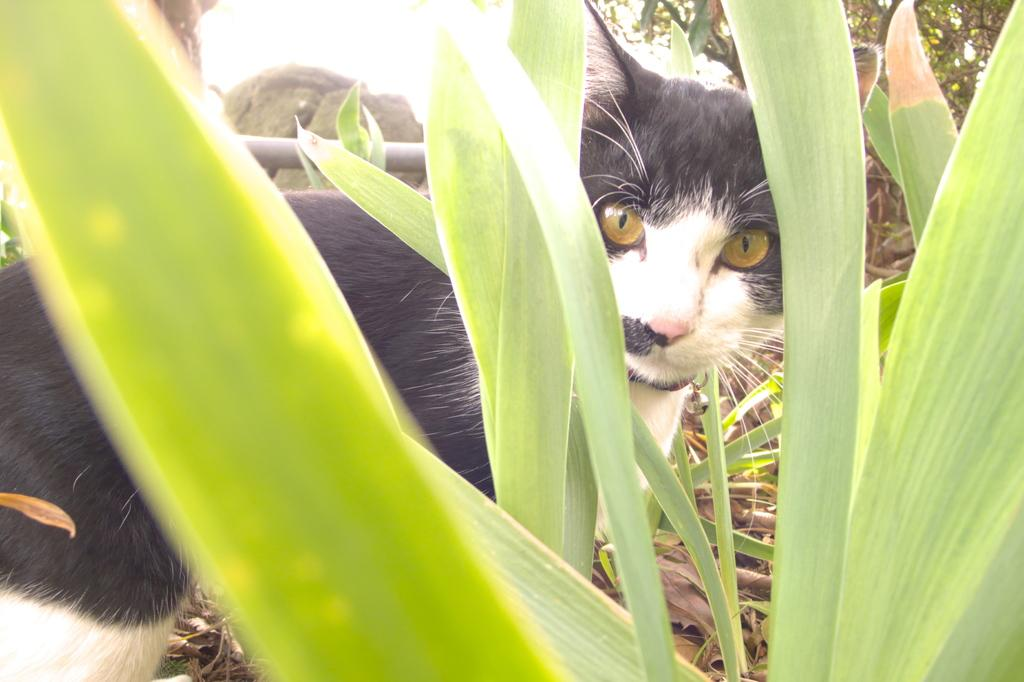What animal is present in the image? There is a cat in the image. Where is the cat located in relation to the leaves? The cat is between leaves in the image. What can be seen in the background on the right side of the image? There are trees in the background on the right side of the image. What is visible in the background on the left side of the image? There is a pole in the background on the left side of the image. What type of marble is the cat sitting on in the image? There is no marble present in the image; the cat is between leaves. Who is the servant attending to in the image? There is no servant present in the image. 